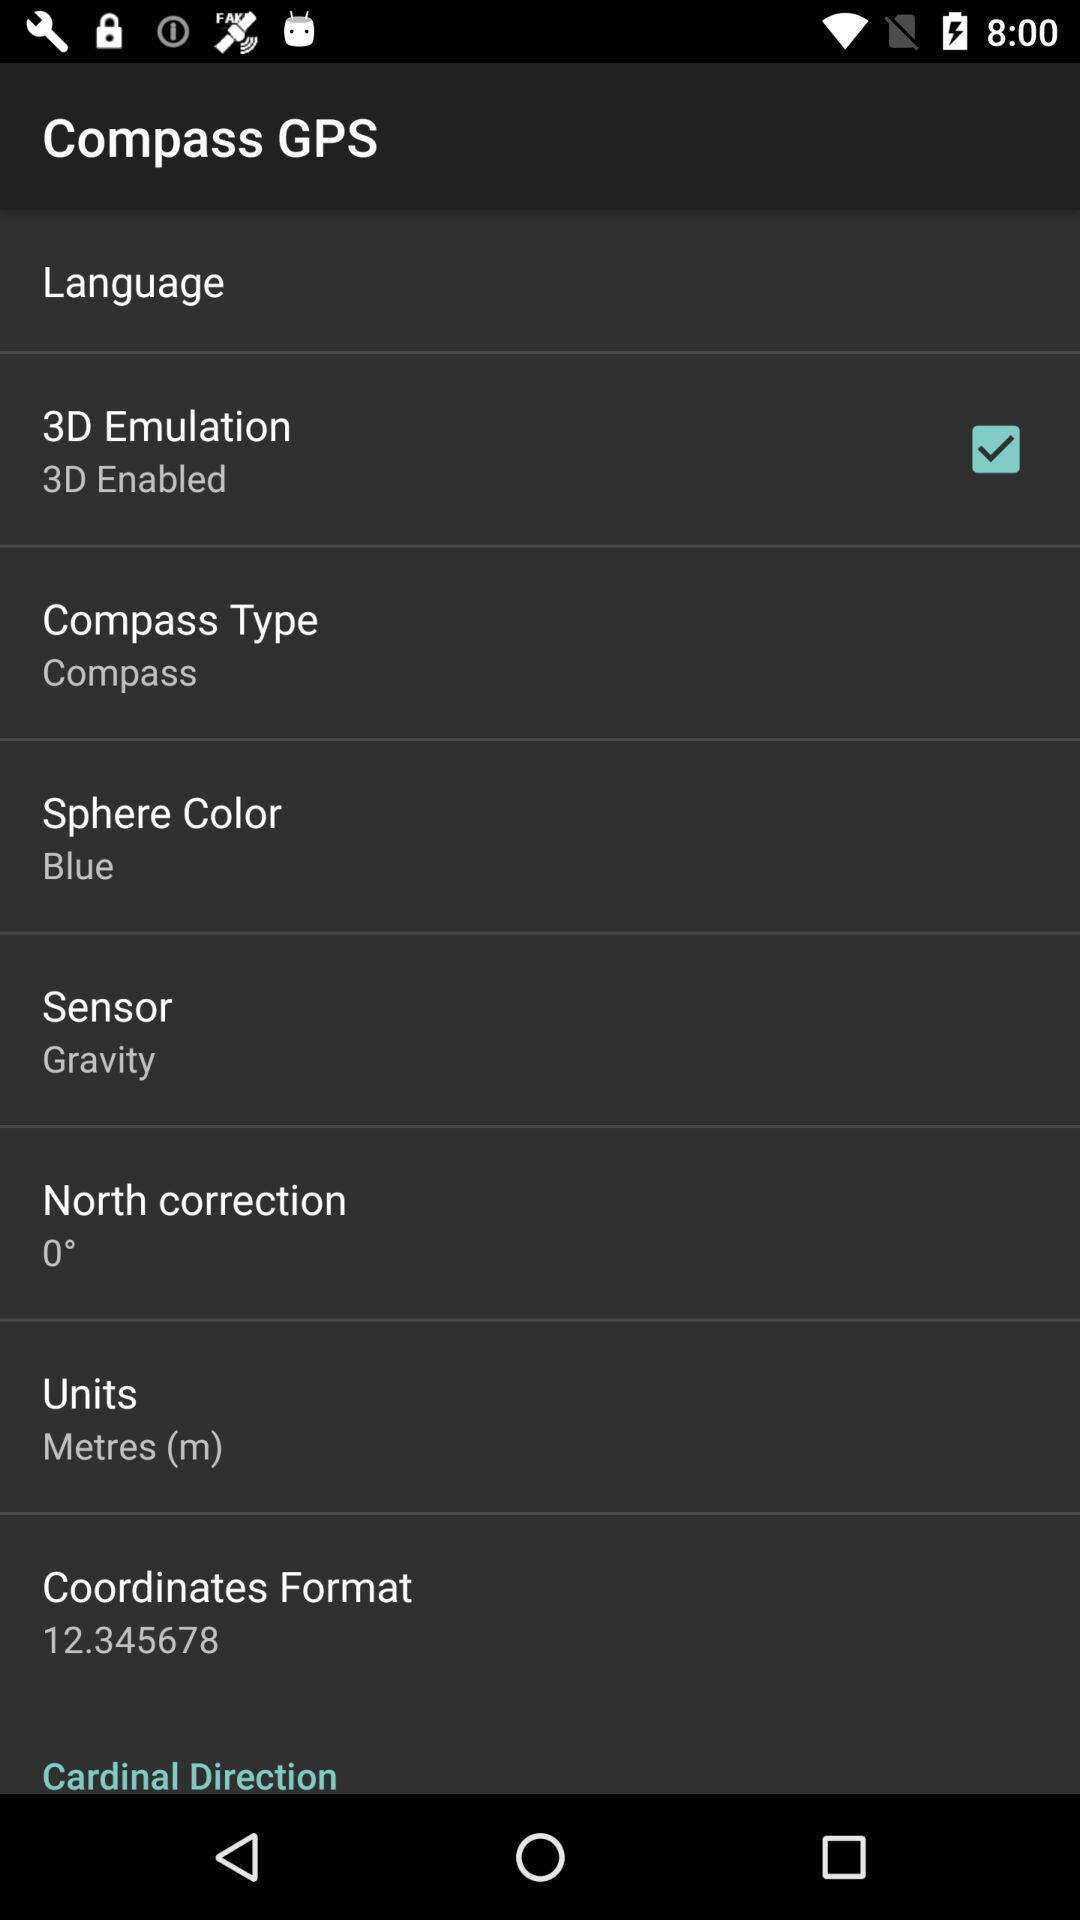What is the bearing? The bearing is 221°. 